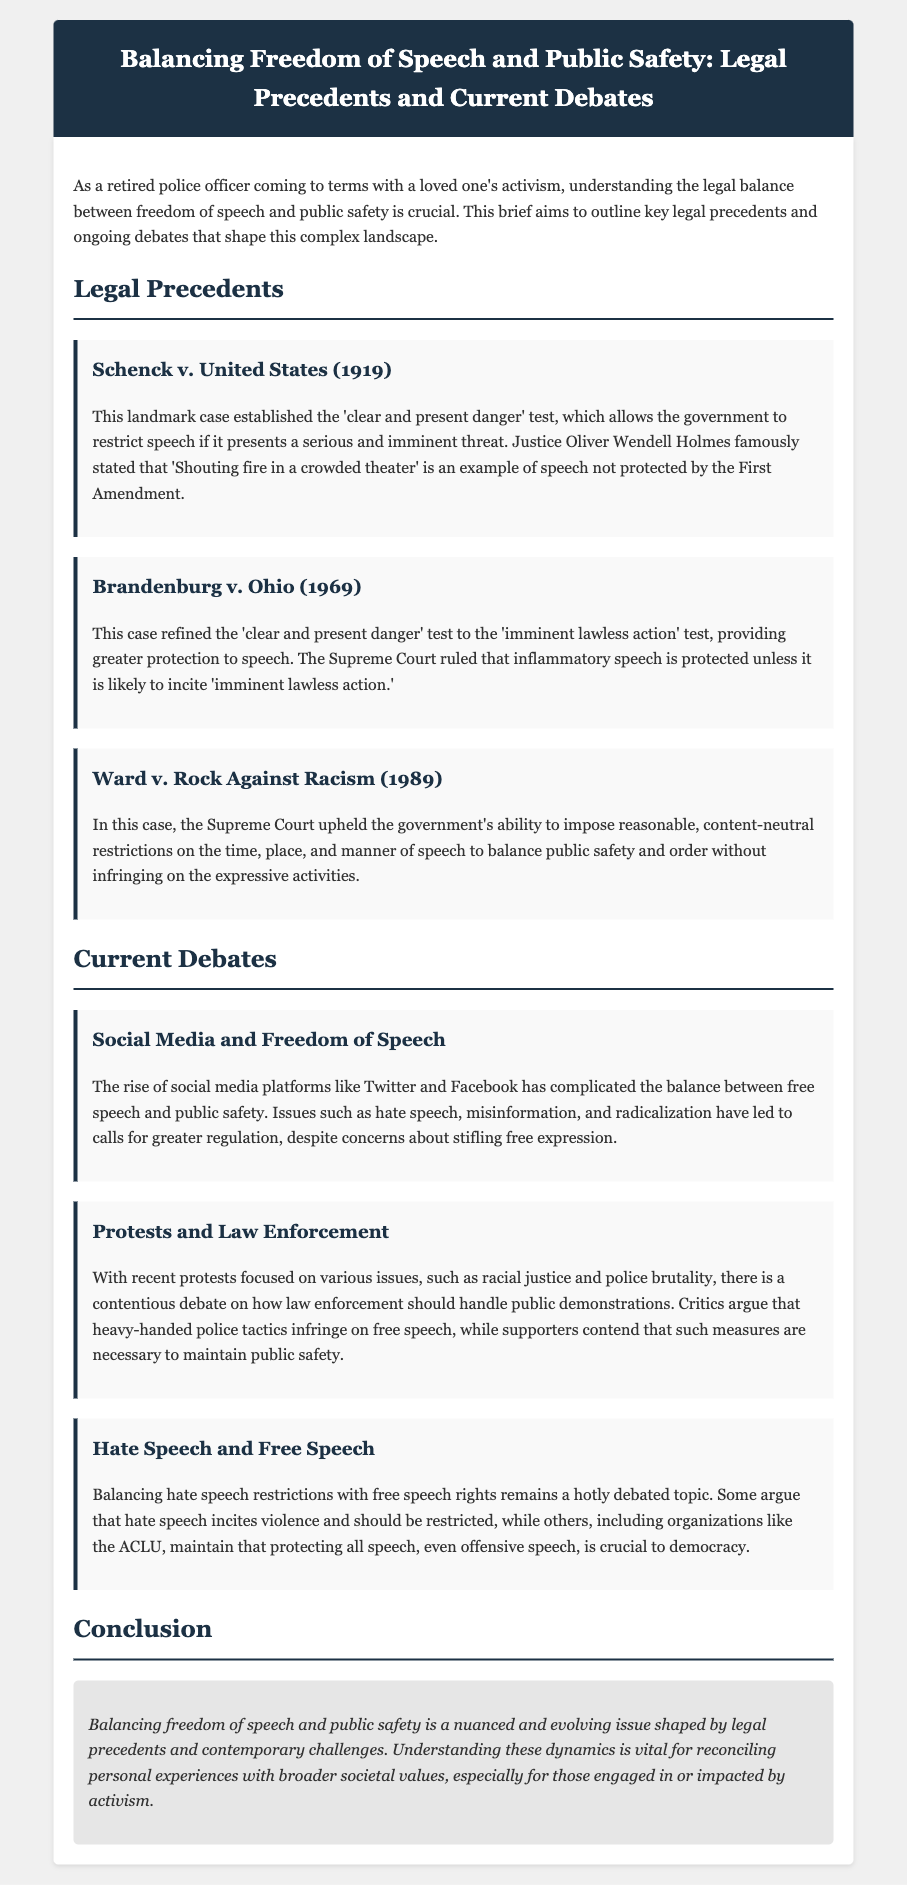What is the title of the brief? The title of the brief is provided in the header section of the document.
Answer: Balancing Freedom of Speech and Public Safety: Legal Precedents and Current Debates Who wrote the opinion in Schenck v. United States? The opinion in Schenck v. United States was written by a prominent Justice.
Answer: Justice Oliver Wendell Holmes What year was Brandenburg v. Ohio decided? The decision date of Brandenburg v. Ohio is specified in the document.
Answer: 1969 What test was established in Schenck v. United States? The test established in Schenck v. United States is a key legal concept mentioned in the text.
Answer: clear and present danger What does the debate about hate speech suggest? The document outlines a significant concern regarding hate speech in the context of free speech rights.
Answer: incites violence What key issue complicates freedom of speech today? The document discusses contemporary challenges related to public safety and free expression.
Answer: Social media What type of restrictions did Ward v. Rock Against Racism uphold? The document specifies the nature of restrictions upheld by the Supreme Court in this case.
Answer: reasonable, content-neutral restrictions In which context are protests and law enforcement debated? The document highlights ongoing discussions regarding protests and the response of police forces to these public demonstrations.
Answer: racial justice and police brutality 